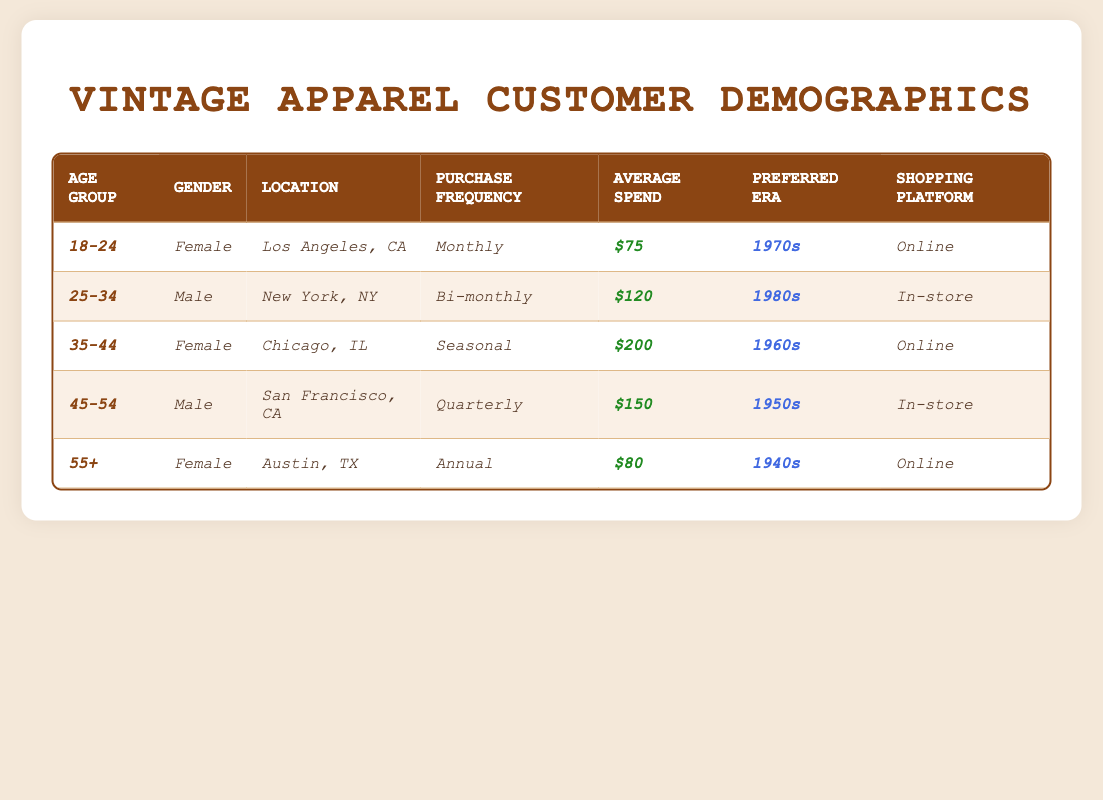What is the preferred era for customers aged 35-44? According to the table, the preferred era for the 35-44 age group is listed as the 1960s.
Answer: 1960s How often do customers aged 25-34 make purchases? The table indicates that customers in the 25-34 age group have a purchase frequency of bi-monthly.
Answer: Bi-monthly What is the average spend of female customers? To find the average, sum the average spends of all female customers: ($75 + $200 + $80) = $355. Divide by 3 to get the average: $355 / 3 = approximately $118.33.
Answer: $118.33 Are there any customers who prefer shopping in-store? The table shows that customers aged 25-34 and 45-54 prefer shopping in-store, indicating that the answer is yes.
Answer: Yes What is the total average spend of all the customers in the table? Summing the average spends of all customers gives: $75 + $120 + $200 + $150 + $80 = $625.
Answer: $625 Which age group has the highest average spend? By comparing the average spends in the table, the 35-44 age group has the highest average spend of $200.
Answer: 35-44 Is the location of the customer who shops online in 1940s vintage apparel in Austin, TX? The table confirms that there is a female customer aged 55+ who is located in Austin, TX and prefers the 1940s vintage apparel. Thus, the statement is true.
Answer: True What is the difference in average spend between the oldest and youngest age groups? The average spend for customers aged 18-24 is $75, and for the 55+ group is $80. The difference is $80 - $75 = $5.
Answer: $5 Which gender has a higher average spend? Calculating the average spend for males: ($120 + $150) = $270; dividing by 2 gives $135. For females: ($75 + $200 + $80) = $355; dividing by 3 gives approximately $118.33. Thus, males have a higher average spend than females.
Answer: Males How many customers prefer the 1970s era? The table shows that only the customer aged 18-24 prefers the 1970s, making it one customer.
Answer: 1 